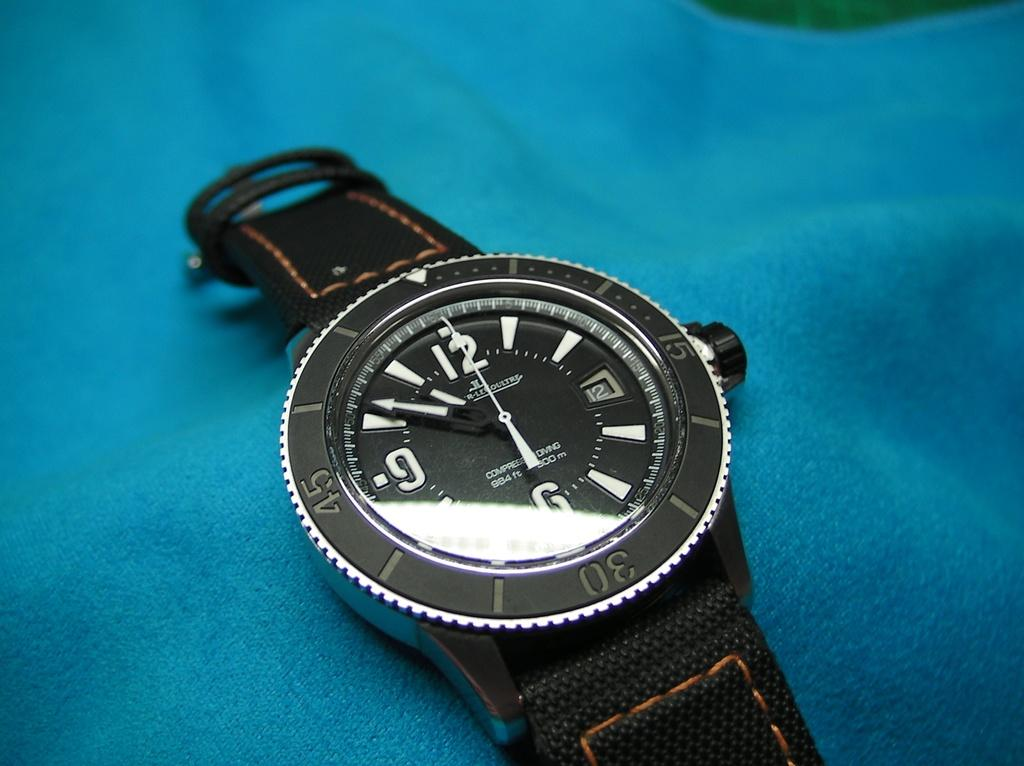Provide a one-sentence caption for the provided image. The watch has a 6 a 9 and a 12 timer. 